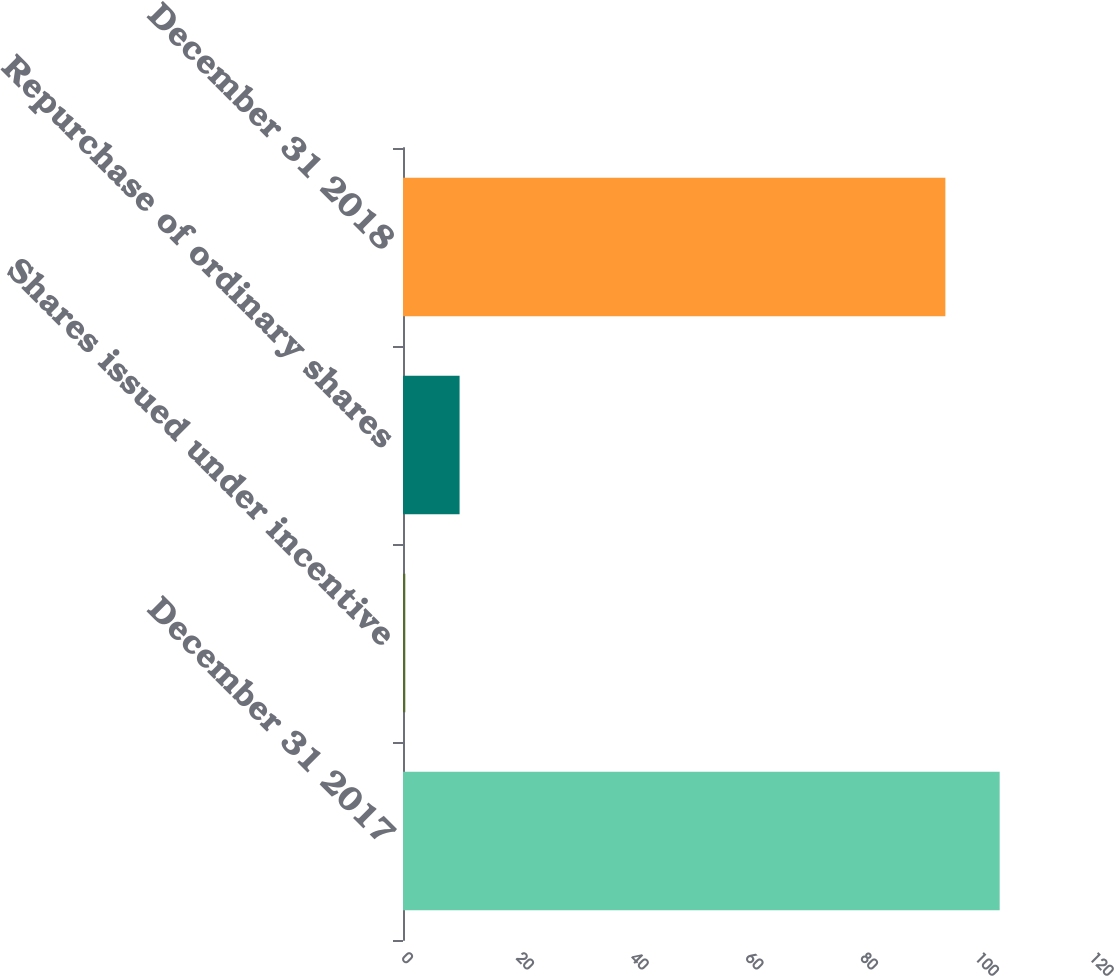Convert chart. <chart><loc_0><loc_0><loc_500><loc_500><bar_chart><fcel>December 31 2017<fcel>Shares issued under incentive<fcel>Repurchase of ordinary shares<fcel>December 31 2018<nl><fcel>104.07<fcel>0.4<fcel>9.87<fcel>94.6<nl></chart> 